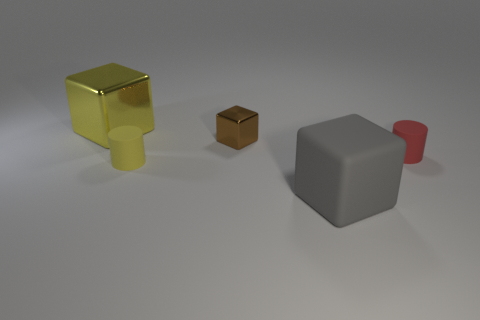Do the big gray object and the big yellow object have the same shape?
Keep it short and to the point. Yes. What material is the large object in front of the metallic cube on the right side of the big yellow block made of?
Offer a very short reply. Rubber. What is the material of the small cylinder that is the same color as the large metallic cube?
Offer a very short reply. Rubber. Do the yellow rubber object and the gray cube have the same size?
Give a very brief answer. No. Are there any things in front of the cylinder to the right of the small block?
Your answer should be compact. Yes. The tiny object that is behind the small red cylinder has what shape?
Offer a terse response. Cube. What number of big things are in front of the tiny rubber thing that is on the right side of the large thing on the right side of the yellow shiny object?
Your answer should be very brief. 1. There is a yellow matte thing; does it have the same size as the metallic thing that is on the right side of the big yellow cube?
Your answer should be compact. Yes. There is a matte cylinder that is to the left of the large thing on the right side of the tiny metallic cube; what is its size?
Your response must be concise. Small. What number of other things are made of the same material as the small brown object?
Your answer should be very brief. 1. 